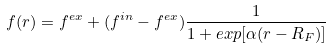Convert formula to latex. <formula><loc_0><loc_0><loc_500><loc_500>f ( r ) = f ^ { e x } + ( f ^ { i n } - f ^ { e x } ) \frac { 1 } { 1 + e x p [ \alpha ( r - R _ { F } ) ] }</formula> 